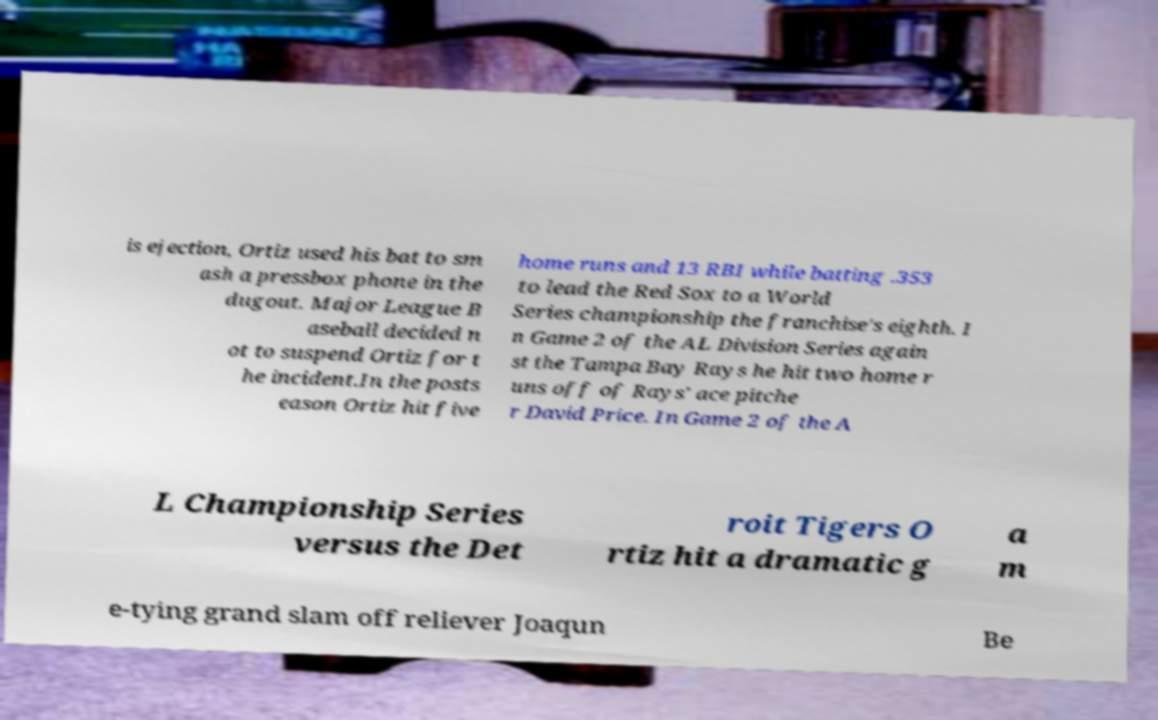There's text embedded in this image that I need extracted. Can you transcribe it verbatim? is ejection, Ortiz used his bat to sm ash a pressbox phone in the dugout. Major League B aseball decided n ot to suspend Ortiz for t he incident.In the posts eason Ortiz hit five home runs and 13 RBI while batting .353 to lead the Red Sox to a World Series championship the franchise's eighth. I n Game 2 of the AL Division Series again st the Tampa Bay Rays he hit two home r uns off of Rays' ace pitche r David Price. In Game 2 of the A L Championship Series versus the Det roit Tigers O rtiz hit a dramatic g a m e-tying grand slam off reliever Joaqun Be 